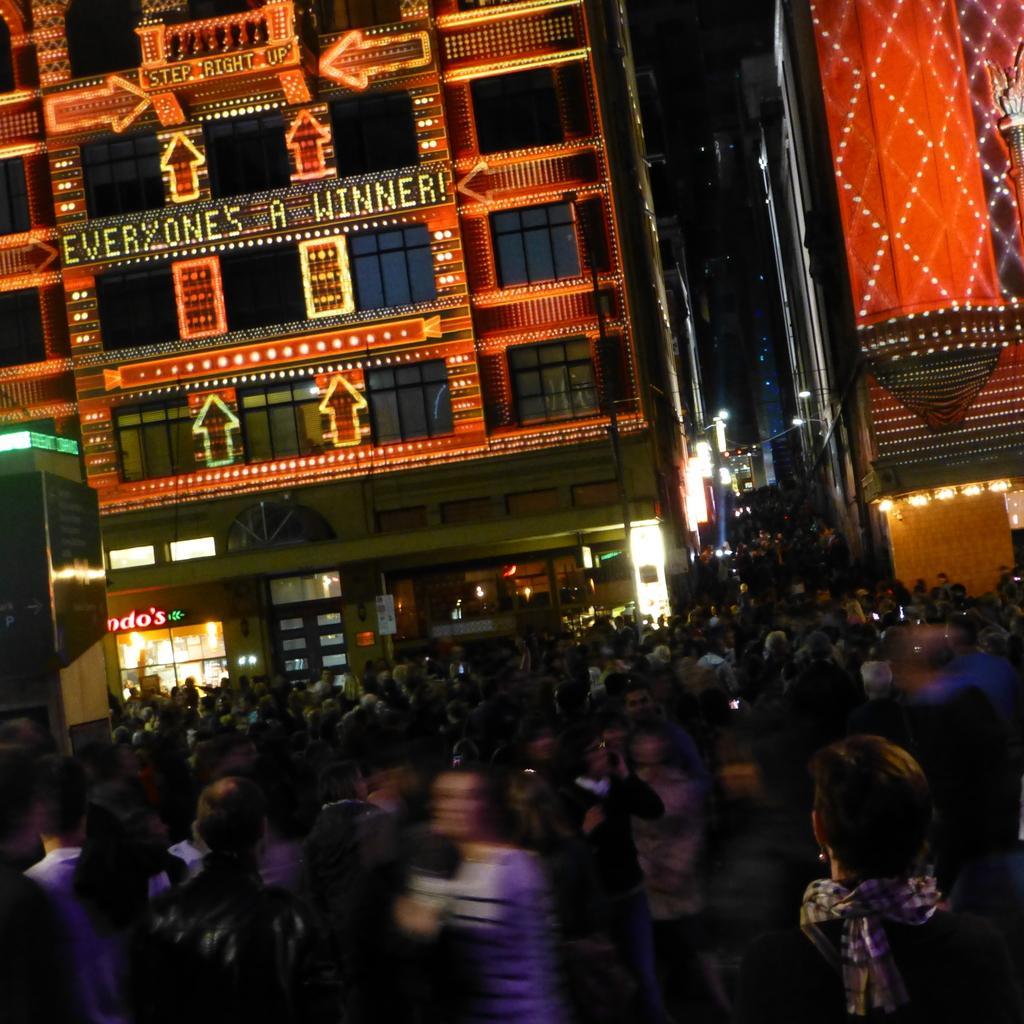Can you describe this image briefly? This image is taken during the night time. In this image we can see the buildings with lightning. We can also see the lights. At the bottom we can see many people. 